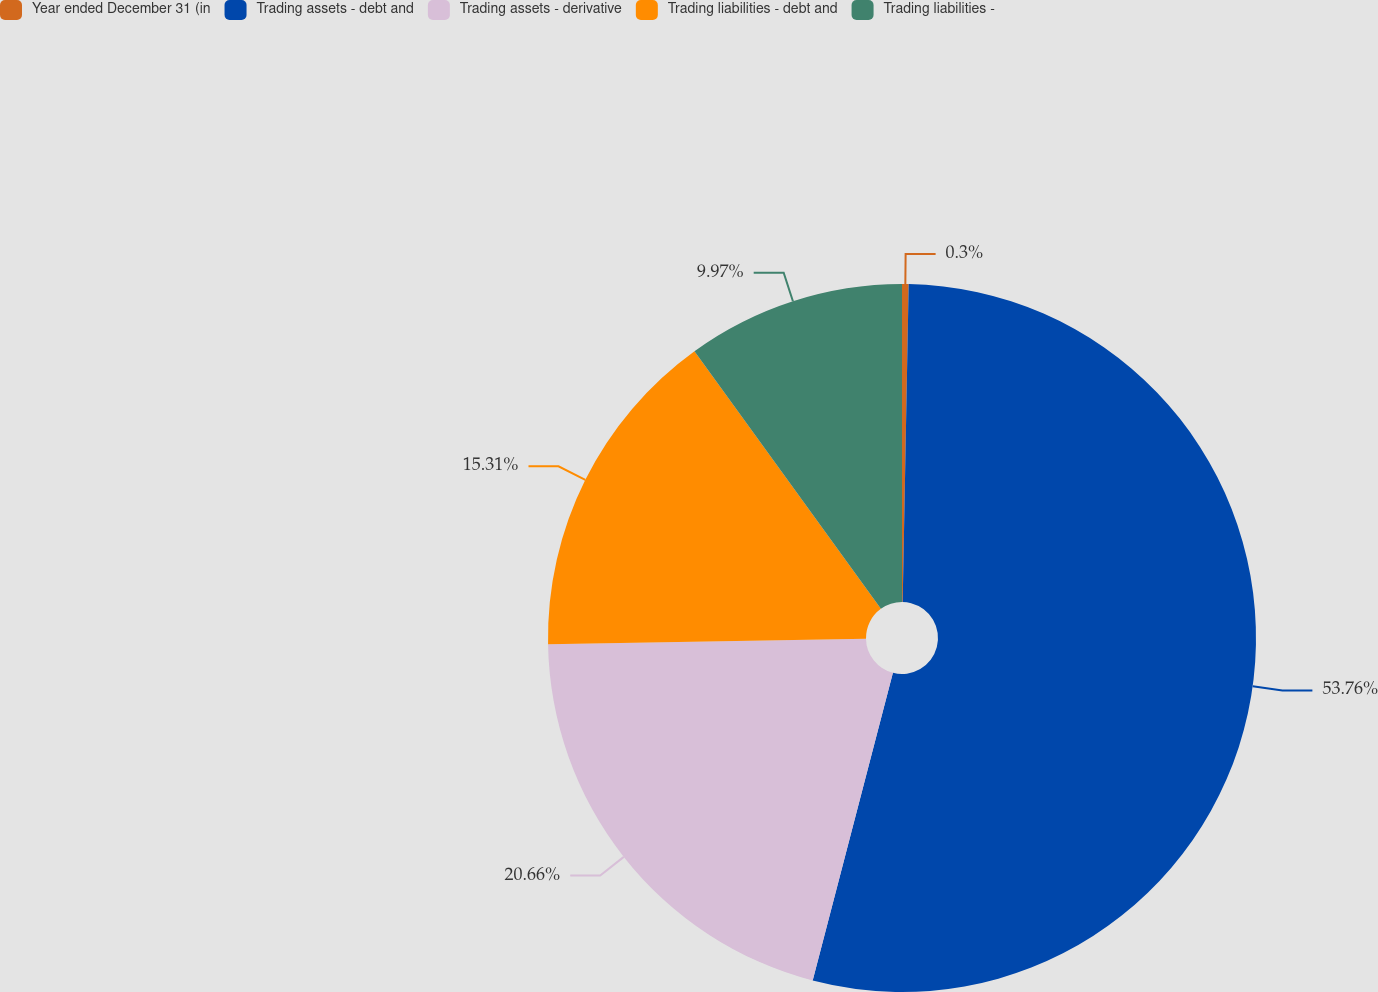<chart> <loc_0><loc_0><loc_500><loc_500><pie_chart><fcel>Year ended December 31 (in<fcel>Trading assets - debt and<fcel>Trading assets - derivative<fcel>Trading liabilities - debt and<fcel>Trading liabilities -<nl><fcel>0.3%<fcel>53.76%<fcel>20.66%<fcel>15.31%<fcel>9.97%<nl></chart> 